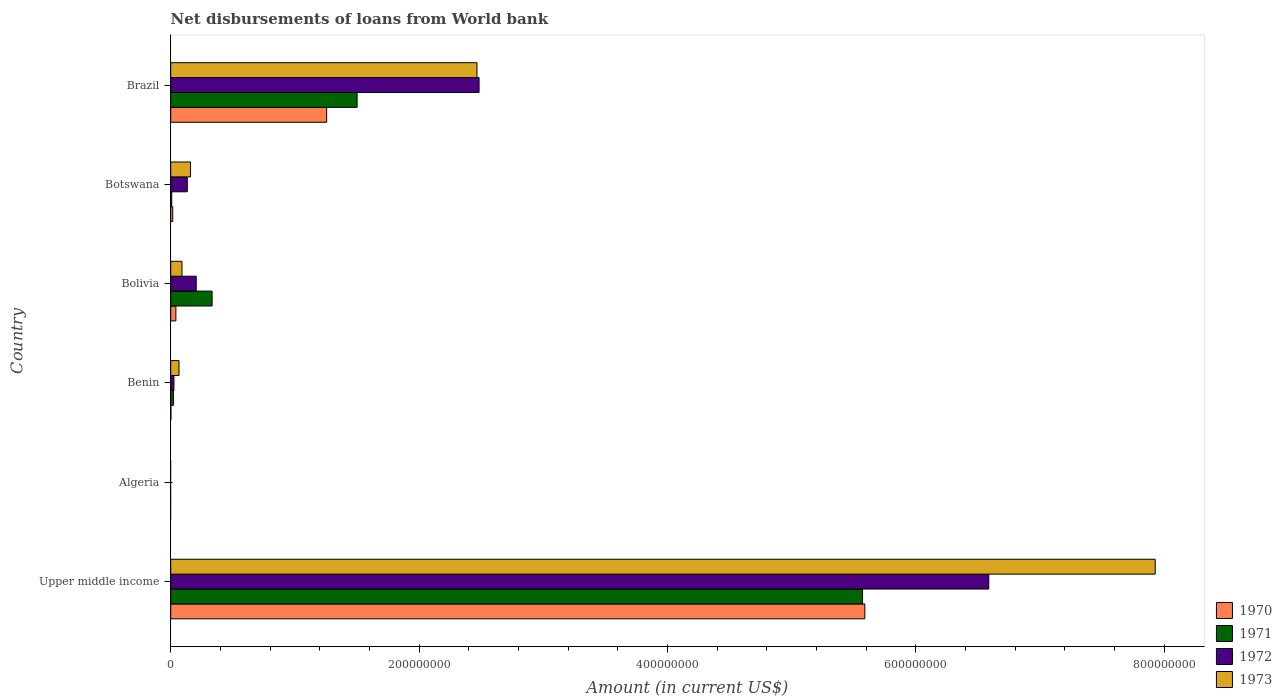How many different coloured bars are there?
Give a very brief answer. 4. Are the number of bars on each tick of the Y-axis equal?
Offer a terse response. No. What is the label of the 5th group of bars from the top?
Offer a very short reply. Algeria. In how many cases, is the number of bars for a given country not equal to the number of legend labels?
Your answer should be compact. 1. What is the amount of loan disbursed from World Bank in 1971 in Brazil?
Ensure brevity in your answer.  1.50e+08. Across all countries, what is the maximum amount of loan disbursed from World Bank in 1973?
Provide a succinct answer. 7.93e+08. Across all countries, what is the minimum amount of loan disbursed from World Bank in 1970?
Provide a short and direct response. 0. In which country was the amount of loan disbursed from World Bank in 1971 maximum?
Keep it short and to the point. Upper middle income. What is the total amount of loan disbursed from World Bank in 1970 in the graph?
Offer a terse response. 6.90e+08. What is the difference between the amount of loan disbursed from World Bank in 1970 in Benin and that in Brazil?
Give a very brief answer. -1.25e+08. What is the difference between the amount of loan disbursed from World Bank in 1972 in Bolivia and the amount of loan disbursed from World Bank in 1973 in Benin?
Make the answer very short. 1.38e+07. What is the average amount of loan disbursed from World Bank in 1973 per country?
Provide a short and direct response. 1.79e+08. What is the difference between the amount of loan disbursed from World Bank in 1971 and amount of loan disbursed from World Bank in 1970 in Benin?
Keep it short and to the point. 2.04e+06. What is the ratio of the amount of loan disbursed from World Bank in 1971 in Bolivia to that in Botswana?
Give a very brief answer. 40.97. What is the difference between the highest and the second highest amount of loan disbursed from World Bank in 1973?
Make the answer very short. 5.46e+08. What is the difference between the highest and the lowest amount of loan disbursed from World Bank in 1970?
Give a very brief answer. 5.59e+08. Is the sum of the amount of loan disbursed from World Bank in 1972 in Botswana and Upper middle income greater than the maximum amount of loan disbursed from World Bank in 1971 across all countries?
Keep it short and to the point. Yes. Is it the case that in every country, the sum of the amount of loan disbursed from World Bank in 1973 and amount of loan disbursed from World Bank in 1972 is greater than the sum of amount of loan disbursed from World Bank in 1970 and amount of loan disbursed from World Bank in 1971?
Provide a short and direct response. No. Is it the case that in every country, the sum of the amount of loan disbursed from World Bank in 1970 and amount of loan disbursed from World Bank in 1972 is greater than the amount of loan disbursed from World Bank in 1971?
Keep it short and to the point. No. What is the difference between two consecutive major ticks on the X-axis?
Your answer should be very brief. 2.00e+08. Does the graph contain any zero values?
Make the answer very short. Yes. What is the title of the graph?
Provide a succinct answer. Net disbursements of loans from World bank. Does "1988" appear as one of the legend labels in the graph?
Keep it short and to the point. No. What is the label or title of the X-axis?
Give a very brief answer. Amount (in current US$). What is the Amount (in current US$) in 1970 in Upper middle income?
Your response must be concise. 5.59e+08. What is the Amount (in current US$) in 1971 in Upper middle income?
Your answer should be compact. 5.57e+08. What is the Amount (in current US$) of 1972 in Upper middle income?
Make the answer very short. 6.59e+08. What is the Amount (in current US$) in 1973 in Upper middle income?
Provide a short and direct response. 7.93e+08. What is the Amount (in current US$) of 1970 in Algeria?
Give a very brief answer. 0. What is the Amount (in current US$) in 1973 in Algeria?
Give a very brief answer. 0. What is the Amount (in current US$) in 1970 in Benin?
Provide a short and direct response. 1.45e+05. What is the Amount (in current US$) of 1971 in Benin?
Offer a very short reply. 2.19e+06. What is the Amount (in current US$) in 1972 in Benin?
Offer a very short reply. 2.58e+06. What is the Amount (in current US$) in 1973 in Benin?
Your answer should be compact. 6.67e+06. What is the Amount (in current US$) in 1970 in Bolivia?
Make the answer very short. 4.15e+06. What is the Amount (in current US$) of 1971 in Bolivia?
Your answer should be compact. 3.33e+07. What is the Amount (in current US$) in 1972 in Bolivia?
Provide a succinct answer. 2.05e+07. What is the Amount (in current US$) in 1973 in Bolivia?
Your answer should be very brief. 9.07e+06. What is the Amount (in current US$) of 1970 in Botswana?
Offer a very short reply. 1.61e+06. What is the Amount (in current US$) in 1971 in Botswana?
Ensure brevity in your answer.  8.13e+05. What is the Amount (in current US$) in 1972 in Botswana?
Your answer should be compact. 1.33e+07. What is the Amount (in current US$) of 1973 in Botswana?
Your response must be concise. 1.60e+07. What is the Amount (in current US$) of 1970 in Brazil?
Give a very brief answer. 1.26e+08. What is the Amount (in current US$) in 1971 in Brazil?
Offer a very short reply. 1.50e+08. What is the Amount (in current US$) in 1972 in Brazil?
Provide a short and direct response. 2.48e+08. What is the Amount (in current US$) of 1973 in Brazil?
Your answer should be compact. 2.47e+08. Across all countries, what is the maximum Amount (in current US$) of 1970?
Your answer should be very brief. 5.59e+08. Across all countries, what is the maximum Amount (in current US$) of 1971?
Ensure brevity in your answer.  5.57e+08. Across all countries, what is the maximum Amount (in current US$) of 1972?
Make the answer very short. 6.59e+08. Across all countries, what is the maximum Amount (in current US$) in 1973?
Offer a terse response. 7.93e+08. Across all countries, what is the minimum Amount (in current US$) of 1970?
Offer a very short reply. 0. What is the total Amount (in current US$) in 1970 in the graph?
Offer a very short reply. 6.90e+08. What is the total Amount (in current US$) in 1971 in the graph?
Your answer should be very brief. 7.43e+08. What is the total Amount (in current US$) in 1972 in the graph?
Provide a short and direct response. 9.43e+08. What is the total Amount (in current US$) of 1973 in the graph?
Your answer should be compact. 1.07e+09. What is the difference between the Amount (in current US$) of 1970 in Upper middle income and that in Benin?
Provide a short and direct response. 5.59e+08. What is the difference between the Amount (in current US$) in 1971 in Upper middle income and that in Benin?
Keep it short and to the point. 5.55e+08. What is the difference between the Amount (in current US$) in 1972 in Upper middle income and that in Benin?
Make the answer very short. 6.56e+08. What is the difference between the Amount (in current US$) in 1973 in Upper middle income and that in Benin?
Provide a short and direct response. 7.86e+08. What is the difference between the Amount (in current US$) of 1970 in Upper middle income and that in Bolivia?
Make the answer very short. 5.55e+08. What is the difference between the Amount (in current US$) of 1971 in Upper middle income and that in Bolivia?
Your answer should be compact. 5.24e+08. What is the difference between the Amount (in current US$) of 1972 in Upper middle income and that in Bolivia?
Provide a short and direct response. 6.38e+08. What is the difference between the Amount (in current US$) of 1973 in Upper middle income and that in Bolivia?
Provide a short and direct response. 7.84e+08. What is the difference between the Amount (in current US$) of 1970 in Upper middle income and that in Botswana?
Your response must be concise. 5.57e+08. What is the difference between the Amount (in current US$) of 1971 in Upper middle income and that in Botswana?
Offer a terse response. 5.56e+08. What is the difference between the Amount (in current US$) of 1972 in Upper middle income and that in Botswana?
Your answer should be compact. 6.45e+08. What is the difference between the Amount (in current US$) of 1973 in Upper middle income and that in Botswana?
Make the answer very short. 7.77e+08. What is the difference between the Amount (in current US$) of 1970 in Upper middle income and that in Brazil?
Provide a short and direct response. 4.33e+08. What is the difference between the Amount (in current US$) of 1971 in Upper middle income and that in Brazil?
Provide a short and direct response. 4.07e+08. What is the difference between the Amount (in current US$) in 1972 in Upper middle income and that in Brazil?
Give a very brief answer. 4.10e+08. What is the difference between the Amount (in current US$) of 1973 in Upper middle income and that in Brazil?
Keep it short and to the point. 5.46e+08. What is the difference between the Amount (in current US$) in 1970 in Benin and that in Bolivia?
Provide a short and direct response. -4.00e+06. What is the difference between the Amount (in current US$) in 1971 in Benin and that in Bolivia?
Offer a terse response. -3.11e+07. What is the difference between the Amount (in current US$) of 1972 in Benin and that in Bolivia?
Make the answer very short. -1.79e+07. What is the difference between the Amount (in current US$) of 1973 in Benin and that in Bolivia?
Your answer should be compact. -2.40e+06. What is the difference between the Amount (in current US$) in 1970 in Benin and that in Botswana?
Your answer should be very brief. -1.46e+06. What is the difference between the Amount (in current US$) in 1971 in Benin and that in Botswana?
Offer a terse response. 1.37e+06. What is the difference between the Amount (in current US$) of 1972 in Benin and that in Botswana?
Make the answer very short. -1.08e+07. What is the difference between the Amount (in current US$) of 1973 in Benin and that in Botswana?
Keep it short and to the point. -9.28e+06. What is the difference between the Amount (in current US$) in 1970 in Benin and that in Brazil?
Offer a terse response. -1.25e+08. What is the difference between the Amount (in current US$) of 1971 in Benin and that in Brazil?
Provide a succinct answer. -1.48e+08. What is the difference between the Amount (in current US$) of 1972 in Benin and that in Brazil?
Your answer should be compact. -2.46e+08. What is the difference between the Amount (in current US$) in 1973 in Benin and that in Brazil?
Offer a terse response. -2.40e+08. What is the difference between the Amount (in current US$) in 1970 in Bolivia and that in Botswana?
Keep it short and to the point. 2.54e+06. What is the difference between the Amount (in current US$) in 1971 in Bolivia and that in Botswana?
Your answer should be very brief. 3.25e+07. What is the difference between the Amount (in current US$) in 1972 in Bolivia and that in Botswana?
Keep it short and to the point. 7.17e+06. What is the difference between the Amount (in current US$) of 1973 in Bolivia and that in Botswana?
Your answer should be compact. -6.89e+06. What is the difference between the Amount (in current US$) in 1970 in Bolivia and that in Brazil?
Make the answer very short. -1.21e+08. What is the difference between the Amount (in current US$) in 1971 in Bolivia and that in Brazil?
Give a very brief answer. -1.17e+08. What is the difference between the Amount (in current US$) in 1972 in Bolivia and that in Brazil?
Provide a short and direct response. -2.28e+08. What is the difference between the Amount (in current US$) in 1973 in Bolivia and that in Brazil?
Offer a very short reply. -2.38e+08. What is the difference between the Amount (in current US$) of 1970 in Botswana and that in Brazil?
Your answer should be very brief. -1.24e+08. What is the difference between the Amount (in current US$) of 1971 in Botswana and that in Brazil?
Your answer should be very brief. -1.49e+08. What is the difference between the Amount (in current US$) in 1972 in Botswana and that in Brazil?
Your response must be concise. -2.35e+08. What is the difference between the Amount (in current US$) of 1973 in Botswana and that in Brazil?
Provide a short and direct response. -2.31e+08. What is the difference between the Amount (in current US$) in 1970 in Upper middle income and the Amount (in current US$) in 1971 in Benin?
Ensure brevity in your answer.  5.57e+08. What is the difference between the Amount (in current US$) of 1970 in Upper middle income and the Amount (in current US$) of 1972 in Benin?
Make the answer very short. 5.56e+08. What is the difference between the Amount (in current US$) of 1970 in Upper middle income and the Amount (in current US$) of 1973 in Benin?
Provide a succinct answer. 5.52e+08. What is the difference between the Amount (in current US$) in 1971 in Upper middle income and the Amount (in current US$) in 1972 in Benin?
Offer a terse response. 5.55e+08. What is the difference between the Amount (in current US$) of 1971 in Upper middle income and the Amount (in current US$) of 1973 in Benin?
Your answer should be very brief. 5.50e+08. What is the difference between the Amount (in current US$) in 1972 in Upper middle income and the Amount (in current US$) in 1973 in Benin?
Make the answer very short. 6.52e+08. What is the difference between the Amount (in current US$) in 1970 in Upper middle income and the Amount (in current US$) in 1971 in Bolivia?
Provide a short and direct response. 5.26e+08. What is the difference between the Amount (in current US$) of 1970 in Upper middle income and the Amount (in current US$) of 1972 in Bolivia?
Your answer should be compact. 5.38e+08. What is the difference between the Amount (in current US$) of 1970 in Upper middle income and the Amount (in current US$) of 1973 in Bolivia?
Provide a short and direct response. 5.50e+08. What is the difference between the Amount (in current US$) of 1971 in Upper middle income and the Amount (in current US$) of 1972 in Bolivia?
Keep it short and to the point. 5.37e+08. What is the difference between the Amount (in current US$) in 1971 in Upper middle income and the Amount (in current US$) in 1973 in Bolivia?
Offer a terse response. 5.48e+08. What is the difference between the Amount (in current US$) of 1972 in Upper middle income and the Amount (in current US$) of 1973 in Bolivia?
Provide a short and direct response. 6.50e+08. What is the difference between the Amount (in current US$) of 1970 in Upper middle income and the Amount (in current US$) of 1971 in Botswana?
Provide a short and direct response. 5.58e+08. What is the difference between the Amount (in current US$) of 1970 in Upper middle income and the Amount (in current US$) of 1972 in Botswana?
Your response must be concise. 5.46e+08. What is the difference between the Amount (in current US$) in 1970 in Upper middle income and the Amount (in current US$) in 1973 in Botswana?
Provide a succinct answer. 5.43e+08. What is the difference between the Amount (in current US$) in 1971 in Upper middle income and the Amount (in current US$) in 1972 in Botswana?
Provide a succinct answer. 5.44e+08. What is the difference between the Amount (in current US$) of 1971 in Upper middle income and the Amount (in current US$) of 1973 in Botswana?
Offer a very short reply. 5.41e+08. What is the difference between the Amount (in current US$) in 1972 in Upper middle income and the Amount (in current US$) in 1973 in Botswana?
Ensure brevity in your answer.  6.43e+08. What is the difference between the Amount (in current US$) of 1970 in Upper middle income and the Amount (in current US$) of 1971 in Brazil?
Ensure brevity in your answer.  4.09e+08. What is the difference between the Amount (in current US$) in 1970 in Upper middle income and the Amount (in current US$) in 1972 in Brazil?
Provide a succinct answer. 3.11e+08. What is the difference between the Amount (in current US$) in 1970 in Upper middle income and the Amount (in current US$) in 1973 in Brazil?
Make the answer very short. 3.12e+08. What is the difference between the Amount (in current US$) in 1971 in Upper middle income and the Amount (in current US$) in 1972 in Brazil?
Offer a very short reply. 3.09e+08. What is the difference between the Amount (in current US$) of 1971 in Upper middle income and the Amount (in current US$) of 1973 in Brazil?
Offer a terse response. 3.10e+08. What is the difference between the Amount (in current US$) of 1972 in Upper middle income and the Amount (in current US$) of 1973 in Brazil?
Provide a succinct answer. 4.12e+08. What is the difference between the Amount (in current US$) of 1970 in Benin and the Amount (in current US$) of 1971 in Bolivia?
Ensure brevity in your answer.  -3.32e+07. What is the difference between the Amount (in current US$) of 1970 in Benin and the Amount (in current US$) of 1972 in Bolivia?
Provide a succinct answer. -2.04e+07. What is the difference between the Amount (in current US$) of 1970 in Benin and the Amount (in current US$) of 1973 in Bolivia?
Keep it short and to the point. -8.92e+06. What is the difference between the Amount (in current US$) of 1971 in Benin and the Amount (in current US$) of 1972 in Bolivia?
Keep it short and to the point. -1.83e+07. What is the difference between the Amount (in current US$) in 1971 in Benin and the Amount (in current US$) in 1973 in Bolivia?
Make the answer very short. -6.88e+06. What is the difference between the Amount (in current US$) of 1972 in Benin and the Amount (in current US$) of 1973 in Bolivia?
Give a very brief answer. -6.49e+06. What is the difference between the Amount (in current US$) in 1970 in Benin and the Amount (in current US$) in 1971 in Botswana?
Keep it short and to the point. -6.68e+05. What is the difference between the Amount (in current US$) in 1970 in Benin and the Amount (in current US$) in 1972 in Botswana?
Make the answer very short. -1.32e+07. What is the difference between the Amount (in current US$) in 1970 in Benin and the Amount (in current US$) in 1973 in Botswana?
Your response must be concise. -1.58e+07. What is the difference between the Amount (in current US$) of 1971 in Benin and the Amount (in current US$) of 1972 in Botswana?
Your answer should be compact. -1.12e+07. What is the difference between the Amount (in current US$) of 1971 in Benin and the Amount (in current US$) of 1973 in Botswana?
Keep it short and to the point. -1.38e+07. What is the difference between the Amount (in current US$) of 1972 in Benin and the Amount (in current US$) of 1973 in Botswana?
Make the answer very short. -1.34e+07. What is the difference between the Amount (in current US$) in 1970 in Benin and the Amount (in current US$) in 1971 in Brazil?
Provide a succinct answer. -1.50e+08. What is the difference between the Amount (in current US$) of 1970 in Benin and the Amount (in current US$) of 1972 in Brazil?
Provide a succinct answer. -2.48e+08. What is the difference between the Amount (in current US$) of 1970 in Benin and the Amount (in current US$) of 1973 in Brazil?
Your answer should be very brief. -2.46e+08. What is the difference between the Amount (in current US$) in 1971 in Benin and the Amount (in current US$) in 1972 in Brazil?
Your answer should be compact. -2.46e+08. What is the difference between the Amount (in current US$) in 1971 in Benin and the Amount (in current US$) in 1973 in Brazil?
Your answer should be very brief. -2.44e+08. What is the difference between the Amount (in current US$) in 1972 in Benin and the Amount (in current US$) in 1973 in Brazil?
Your response must be concise. -2.44e+08. What is the difference between the Amount (in current US$) of 1970 in Bolivia and the Amount (in current US$) of 1971 in Botswana?
Offer a very short reply. 3.34e+06. What is the difference between the Amount (in current US$) in 1970 in Bolivia and the Amount (in current US$) in 1972 in Botswana?
Provide a succinct answer. -9.20e+06. What is the difference between the Amount (in current US$) in 1970 in Bolivia and the Amount (in current US$) in 1973 in Botswana?
Offer a terse response. -1.18e+07. What is the difference between the Amount (in current US$) in 1971 in Bolivia and the Amount (in current US$) in 1972 in Botswana?
Provide a succinct answer. 2.00e+07. What is the difference between the Amount (in current US$) in 1971 in Bolivia and the Amount (in current US$) in 1973 in Botswana?
Your answer should be very brief. 1.74e+07. What is the difference between the Amount (in current US$) in 1972 in Bolivia and the Amount (in current US$) in 1973 in Botswana?
Your response must be concise. 4.56e+06. What is the difference between the Amount (in current US$) in 1970 in Bolivia and the Amount (in current US$) in 1971 in Brazil?
Your answer should be very brief. -1.46e+08. What is the difference between the Amount (in current US$) of 1970 in Bolivia and the Amount (in current US$) of 1972 in Brazil?
Offer a very short reply. -2.44e+08. What is the difference between the Amount (in current US$) of 1970 in Bolivia and the Amount (in current US$) of 1973 in Brazil?
Your answer should be compact. -2.42e+08. What is the difference between the Amount (in current US$) of 1971 in Bolivia and the Amount (in current US$) of 1972 in Brazil?
Offer a very short reply. -2.15e+08. What is the difference between the Amount (in current US$) of 1971 in Bolivia and the Amount (in current US$) of 1973 in Brazil?
Offer a terse response. -2.13e+08. What is the difference between the Amount (in current US$) of 1972 in Bolivia and the Amount (in current US$) of 1973 in Brazil?
Provide a short and direct response. -2.26e+08. What is the difference between the Amount (in current US$) in 1970 in Botswana and the Amount (in current US$) in 1971 in Brazil?
Give a very brief answer. -1.48e+08. What is the difference between the Amount (in current US$) in 1970 in Botswana and the Amount (in current US$) in 1972 in Brazil?
Offer a very short reply. -2.47e+08. What is the difference between the Amount (in current US$) of 1970 in Botswana and the Amount (in current US$) of 1973 in Brazil?
Give a very brief answer. -2.45e+08. What is the difference between the Amount (in current US$) in 1971 in Botswana and the Amount (in current US$) in 1972 in Brazil?
Provide a succinct answer. -2.47e+08. What is the difference between the Amount (in current US$) of 1971 in Botswana and the Amount (in current US$) of 1973 in Brazil?
Give a very brief answer. -2.46e+08. What is the difference between the Amount (in current US$) of 1972 in Botswana and the Amount (in current US$) of 1973 in Brazil?
Ensure brevity in your answer.  -2.33e+08. What is the average Amount (in current US$) of 1970 per country?
Your answer should be very brief. 1.15e+08. What is the average Amount (in current US$) in 1971 per country?
Ensure brevity in your answer.  1.24e+08. What is the average Amount (in current US$) of 1972 per country?
Offer a very short reply. 1.57e+08. What is the average Amount (in current US$) of 1973 per country?
Provide a short and direct response. 1.79e+08. What is the difference between the Amount (in current US$) in 1970 and Amount (in current US$) in 1971 in Upper middle income?
Your response must be concise. 1.84e+06. What is the difference between the Amount (in current US$) of 1970 and Amount (in current US$) of 1972 in Upper middle income?
Provide a succinct answer. -9.98e+07. What is the difference between the Amount (in current US$) in 1970 and Amount (in current US$) in 1973 in Upper middle income?
Your response must be concise. -2.34e+08. What is the difference between the Amount (in current US$) of 1971 and Amount (in current US$) of 1972 in Upper middle income?
Your answer should be compact. -1.02e+08. What is the difference between the Amount (in current US$) of 1971 and Amount (in current US$) of 1973 in Upper middle income?
Your answer should be compact. -2.36e+08. What is the difference between the Amount (in current US$) of 1972 and Amount (in current US$) of 1973 in Upper middle income?
Your response must be concise. -1.34e+08. What is the difference between the Amount (in current US$) of 1970 and Amount (in current US$) of 1971 in Benin?
Your answer should be very brief. -2.04e+06. What is the difference between the Amount (in current US$) in 1970 and Amount (in current US$) in 1972 in Benin?
Your answer should be compact. -2.43e+06. What is the difference between the Amount (in current US$) of 1970 and Amount (in current US$) of 1973 in Benin?
Ensure brevity in your answer.  -6.53e+06. What is the difference between the Amount (in current US$) of 1971 and Amount (in current US$) of 1972 in Benin?
Give a very brief answer. -3.92e+05. What is the difference between the Amount (in current US$) in 1971 and Amount (in current US$) in 1973 in Benin?
Give a very brief answer. -4.49e+06. What is the difference between the Amount (in current US$) of 1972 and Amount (in current US$) of 1973 in Benin?
Give a very brief answer. -4.09e+06. What is the difference between the Amount (in current US$) of 1970 and Amount (in current US$) of 1971 in Bolivia?
Provide a succinct answer. -2.92e+07. What is the difference between the Amount (in current US$) in 1970 and Amount (in current US$) in 1972 in Bolivia?
Provide a succinct answer. -1.64e+07. What is the difference between the Amount (in current US$) of 1970 and Amount (in current US$) of 1973 in Bolivia?
Make the answer very short. -4.92e+06. What is the difference between the Amount (in current US$) in 1971 and Amount (in current US$) in 1972 in Bolivia?
Your answer should be compact. 1.28e+07. What is the difference between the Amount (in current US$) in 1971 and Amount (in current US$) in 1973 in Bolivia?
Keep it short and to the point. 2.42e+07. What is the difference between the Amount (in current US$) in 1972 and Amount (in current US$) in 1973 in Bolivia?
Keep it short and to the point. 1.14e+07. What is the difference between the Amount (in current US$) in 1970 and Amount (in current US$) in 1971 in Botswana?
Offer a very short reply. 7.94e+05. What is the difference between the Amount (in current US$) of 1970 and Amount (in current US$) of 1972 in Botswana?
Your answer should be very brief. -1.17e+07. What is the difference between the Amount (in current US$) in 1970 and Amount (in current US$) in 1973 in Botswana?
Provide a succinct answer. -1.43e+07. What is the difference between the Amount (in current US$) in 1971 and Amount (in current US$) in 1972 in Botswana?
Keep it short and to the point. -1.25e+07. What is the difference between the Amount (in current US$) of 1971 and Amount (in current US$) of 1973 in Botswana?
Provide a short and direct response. -1.51e+07. What is the difference between the Amount (in current US$) in 1972 and Amount (in current US$) in 1973 in Botswana?
Ensure brevity in your answer.  -2.61e+06. What is the difference between the Amount (in current US$) in 1970 and Amount (in current US$) in 1971 in Brazil?
Keep it short and to the point. -2.45e+07. What is the difference between the Amount (in current US$) in 1970 and Amount (in current US$) in 1972 in Brazil?
Give a very brief answer. -1.23e+08. What is the difference between the Amount (in current US$) of 1970 and Amount (in current US$) of 1973 in Brazil?
Make the answer very short. -1.21e+08. What is the difference between the Amount (in current US$) of 1971 and Amount (in current US$) of 1972 in Brazil?
Keep it short and to the point. -9.82e+07. What is the difference between the Amount (in current US$) in 1971 and Amount (in current US$) in 1973 in Brazil?
Give a very brief answer. -9.65e+07. What is the difference between the Amount (in current US$) of 1972 and Amount (in current US$) of 1973 in Brazil?
Ensure brevity in your answer.  1.69e+06. What is the ratio of the Amount (in current US$) of 1970 in Upper middle income to that in Benin?
Make the answer very short. 3854.79. What is the ratio of the Amount (in current US$) of 1971 in Upper middle income to that in Benin?
Provide a succinct answer. 254.85. What is the ratio of the Amount (in current US$) in 1972 in Upper middle income to that in Benin?
Your answer should be very brief. 255.52. What is the ratio of the Amount (in current US$) in 1973 in Upper middle income to that in Benin?
Give a very brief answer. 118.82. What is the ratio of the Amount (in current US$) in 1970 in Upper middle income to that in Bolivia?
Offer a terse response. 134.72. What is the ratio of the Amount (in current US$) of 1971 in Upper middle income to that in Bolivia?
Your answer should be very brief. 16.73. What is the ratio of the Amount (in current US$) of 1972 in Upper middle income to that in Bolivia?
Your answer should be very brief. 32.1. What is the ratio of the Amount (in current US$) in 1973 in Upper middle income to that in Bolivia?
Keep it short and to the point. 87.41. What is the ratio of the Amount (in current US$) in 1970 in Upper middle income to that in Botswana?
Provide a short and direct response. 347.82. What is the ratio of the Amount (in current US$) of 1971 in Upper middle income to that in Botswana?
Offer a terse response. 685.24. What is the ratio of the Amount (in current US$) in 1972 in Upper middle income to that in Botswana?
Your answer should be very brief. 49.35. What is the ratio of the Amount (in current US$) of 1973 in Upper middle income to that in Botswana?
Offer a very short reply. 49.68. What is the ratio of the Amount (in current US$) of 1970 in Upper middle income to that in Brazil?
Offer a very short reply. 4.45. What is the ratio of the Amount (in current US$) in 1971 in Upper middle income to that in Brazil?
Offer a very short reply. 3.71. What is the ratio of the Amount (in current US$) of 1972 in Upper middle income to that in Brazil?
Give a very brief answer. 2.65. What is the ratio of the Amount (in current US$) in 1973 in Upper middle income to that in Brazil?
Your answer should be very brief. 3.21. What is the ratio of the Amount (in current US$) of 1970 in Benin to that in Bolivia?
Give a very brief answer. 0.03. What is the ratio of the Amount (in current US$) of 1971 in Benin to that in Bolivia?
Ensure brevity in your answer.  0.07. What is the ratio of the Amount (in current US$) in 1972 in Benin to that in Bolivia?
Your answer should be very brief. 0.13. What is the ratio of the Amount (in current US$) of 1973 in Benin to that in Bolivia?
Give a very brief answer. 0.74. What is the ratio of the Amount (in current US$) in 1970 in Benin to that in Botswana?
Provide a short and direct response. 0.09. What is the ratio of the Amount (in current US$) in 1971 in Benin to that in Botswana?
Your answer should be very brief. 2.69. What is the ratio of the Amount (in current US$) in 1972 in Benin to that in Botswana?
Make the answer very short. 0.19. What is the ratio of the Amount (in current US$) of 1973 in Benin to that in Botswana?
Provide a succinct answer. 0.42. What is the ratio of the Amount (in current US$) of 1970 in Benin to that in Brazil?
Give a very brief answer. 0. What is the ratio of the Amount (in current US$) of 1971 in Benin to that in Brazil?
Ensure brevity in your answer.  0.01. What is the ratio of the Amount (in current US$) in 1972 in Benin to that in Brazil?
Ensure brevity in your answer.  0.01. What is the ratio of the Amount (in current US$) of 1973 in Benin to that in Brazil?
Keep it short and to the point. 0.03. What is the ratio of the Amount (in current US$) of 1970 in Bolivia to that in Botswana?
Give a very brief answer. 2.58. What is the ratio of the Amount (in current US$) of 1971 in Bolivia to that in Botswana?
Keep it short and to the point. 40.97. What is the ratio of the Amount (in current US$) in 1972 in Bolivia to that in Botswana?
Give a very brief answer. 1.54. What is the ratio of the Amount (in current US$) in 1973 in Bolivia to that in Botswana?
Ensure brevity in your answer.  0.57. What is the ratio of the Amount (in current US$) in 1970 in Bolivia to that in Brazil?
Offer a terse response. 0.03. What is the ratio of the Amount (in current US$) of 1971 in Bolivia to that in Brazil?
Offer a terse response. 0.22. What is the ratio of the Amount (in current US$) of 1972 in Bolivia to that in Brazil?
Provide a succinct answer. 0.08. What is the ratio of the Amount (in current US$) in 1973 in Bolivia to that in Brazil?
Make the answer very short. 0.04. What is the ratio of the Amount (in current US$) of 1970 in Botswana to that in Brazil?
Offer a terse response. 0.01. What is the ratio of the Amount (in current US$) of 1971 in Botswana to that in Brazil?
Your response must be concise. 0.01. What is the ratio of the Amount (in current US$) of 1972 in Botswana to that in Brazil?
Keep it short and to the point. 0.05. What is the ratio of the Amount (in current US$) in 1973 in Botswana to that in Brazil?
Make the answer very short. 0.06. What is the difference between the highest and the second highest Amount (in current US$) in 1970?
Offer a terse response. 4.33e+08. What is the difference between the highest and the second highest Amount (in current US$) of 1971?
Offer a terse response. 4.07e+08. What is the difference between the highest and the second highest Amount (in current US$) of 1972?
Ensure brevity in your answer.  4.10e+08. What is the difference between the highest and the second highest Amount (in current US$) in 1973?
Offer a terse response. 5.46e+08. What is the difference between the highest and the lowest Amount (in current US$) of 1970?
Your response must be concise. 5.59e+08. What is the difference between the highest and the lowest Amount (in current US$) in 1971?
Give a very brief answer. 5.57e+08. What is the difference between the highest and the lowest Amount (in current US$) of 1972?
Keep it short and to the point. 6.59e+08. What is the difference between the highest and the lowest Amount (in current US$) in 1973?
Provide a succinct answer. 7.93e+08. 